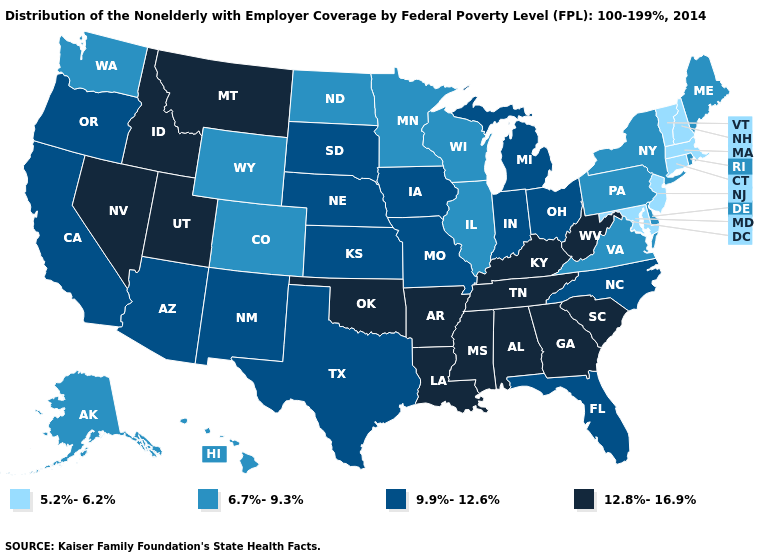Does Illinois have the lowest value in the MidWest?
Keep it brief. Yes. Which states have the lowest value in the USA?
Keep it brief. Connecticut, Maryland, Massachusetts, New Hampshire, New Jersey, Vermont. What is the highest value in states that border Indiana?
Give a very brief answer. 12.8%-16.9%. What is the value of Wisconsin?
Give a very brief answer. 6.7%-9.3%. Which states have the lowest value in the MidWest?
Write a very short answer. Illinois, Minnesota, North Dakota, Wisconsin. What is the value of Kansas?
Be succinct. 9.9%-12.6%. What is the value of Texas?
Write a very short answer. 9.9%-12.6%. What is the value of Montana?
Quick response, please. 12.8%-16.9%. Does Delaware have the same value as Virginia?
Be succinct. Yes. What is the lowest value in the West?
Write a very short answer. 6.7%-9.3%. Does New Jersey have a lower value than Maine?
Quick response, please. Yes. Does Indiana have the lowest value in the USA?
Quick response, please. No. What is the value of Florida?
Concise answer only. 9.9%-12.6%. Which states have the lowest value in the USA?
Write a very short answer. Connecticut, Maryland, Massachusetts, New Hampshire, New Jersey, Vermont. 